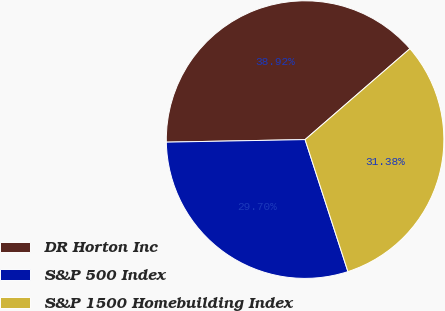Convert chart to OTSL. <chart><loc_0><loc_0><loc_500><loc_500><pie_chart><fcel>DR Horton Inc<fcel>S&P 500 Index<fcel>S&P 1500 Homebuilding Index<nl><fcel>38.92%<fcel>29.7%<fcel>31.38%<nl></chart> 